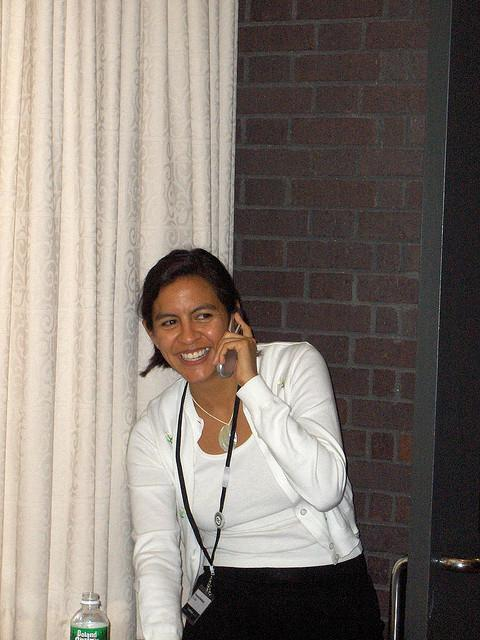How is she communicating? phone 